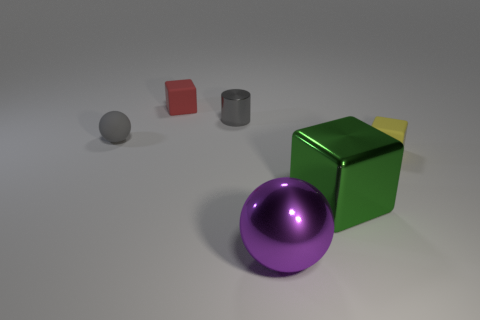What is the color of the sphere that is the same material as the red block?
Keep it short and to the point. Gray. Is the number of purple metallic cylinders less than the number of metallic spheres?
Your response must be concise. Yes. There is a metallic thing behind the tiny yellow rubber block; does it have the same shape as the large metallic object behind the large purple object?
Provide a succinct answer. No. What number of things are either large green cubes or large purple objects?
Ensure brevity in your answer.  2. What color is the ball that is the same size as the gray cylinder?
Keep it short and to the point. Gray. How many gray shiny cylinders are in front of the metal thing that is behind the rubber ball?
Give a very brief answer. 0. What number of spheres are both behind the purple shiny sphere and in front of the green metallic cube?
Keep it short and to the point. 0. How many objects are small rubber cubes in front of the gray shiny thing or spheres behind the purple ball?
Provide a succinct answer. 2. What number of other things are the same size as the metallic block?
Provide a succinct answer. 1. What shape is the object behind the shiny object that is behind the small rubber ball?
Offer a very short reply. Cube. 